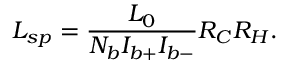<formula> <loc_0><loc_0><loc_500><loc_500>L _ { s p } = \frac { L _ { 0 } } { N _ { b } I _ { b + } I _ { b - } } R _ { C } R _ { H } .</formula> 